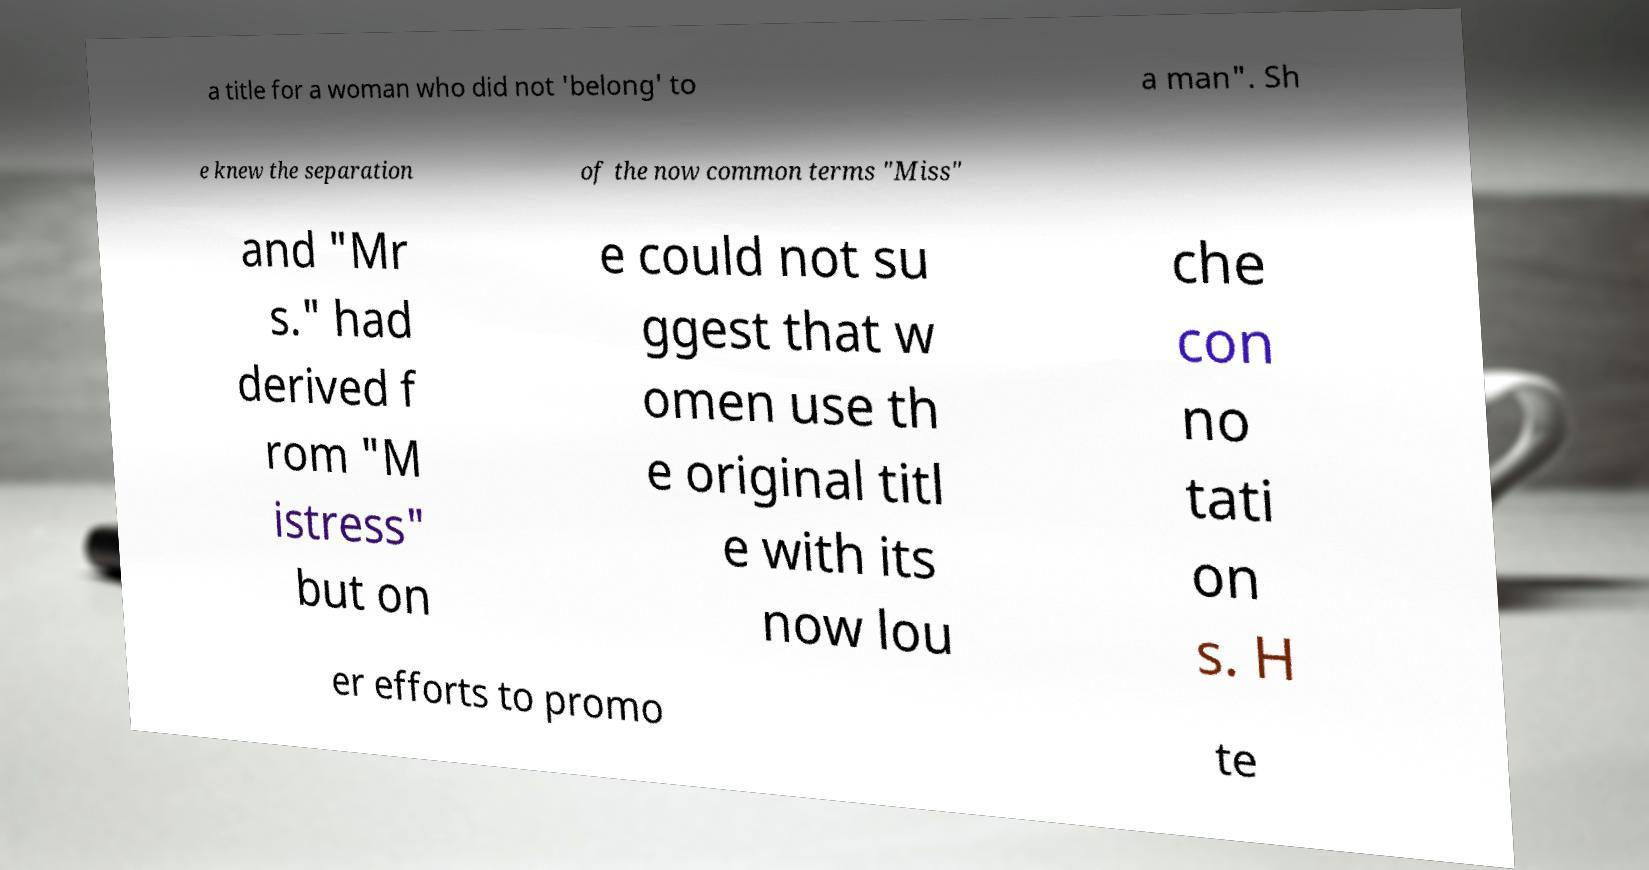Could you extract and type out the text from this image? a title for a woman who did not 'belong' to a man". Sh e knew the separation of the now common terms "Miss" and "Mr s." had derived f rom "M istress" but on e could not su ggest that w omen use th e original titl e with its now lou che con no tati on s. H er efforts to promo te 